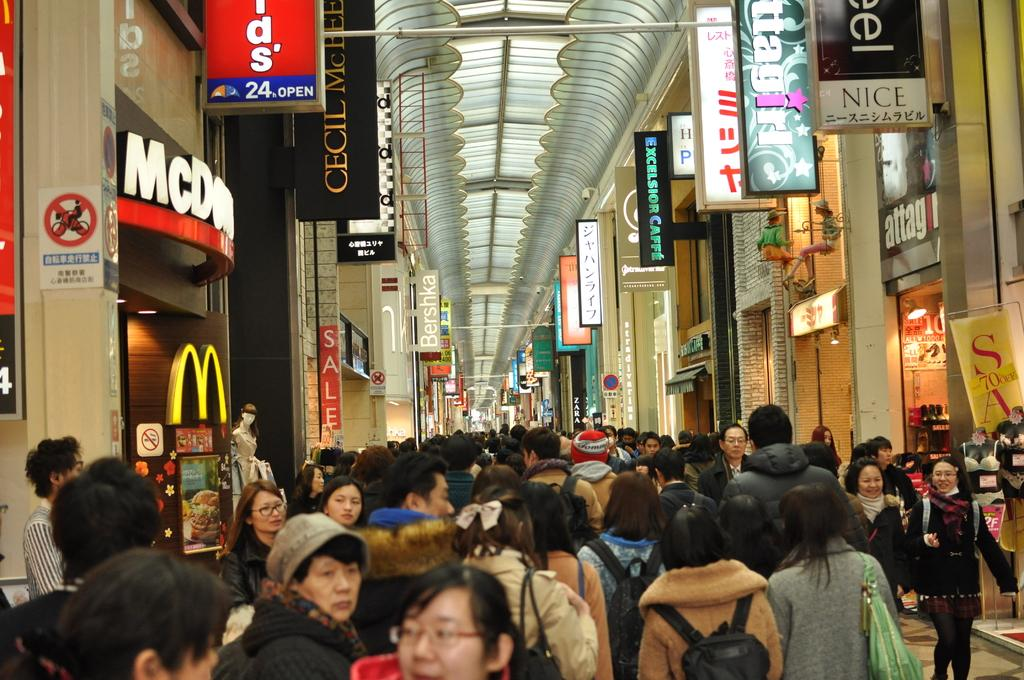How many people are in the image? There is a group of people in the image, but the exact number cannot be determined from the provided facts. What type of establishments can be seen in the image? There are shops visible in the image. What can be seen in the background of the image? In the background of the image, there are boards, lights, poles, and a roof. Can you describe the lighting conditions in the image? The presence of lights in the background suggests that the image is well-lit. What type of desk can be seen in the image? There is no desk present in the image. What kind of noise can be heard coming from the shops in the image? The image is a still picture, so no noise can be heard. 